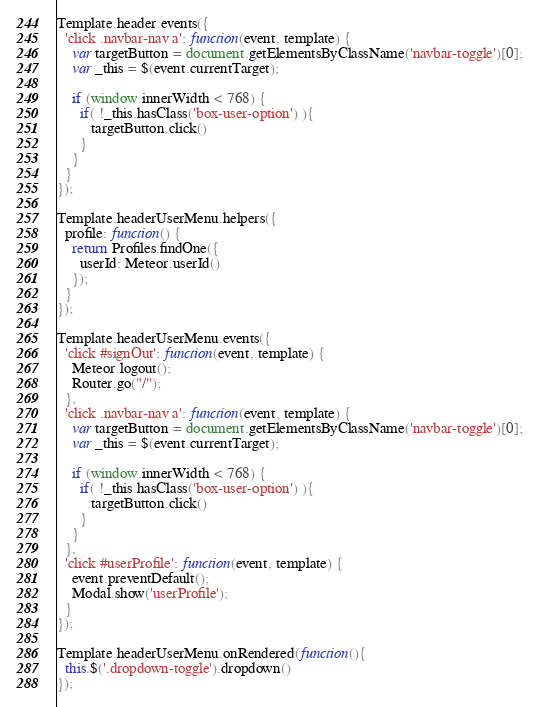Convert code to text. <code><loc_0><loc_0><loc_500><loc_500><_JavaScript_>Template.header.events({
  'click .navbar-nav a': function(event, template) {
    var targetButton = document.getElementsByClassName('navbar-toggle')[0];
    var _this = $(event.currentTarget); 

    if (window.innerWidth < 768) {
      if( !_this.hasClass('box-user-option') ){
         targetButton.click()
      }
    }
  }
});

Template.headerUserMenu.helpers({
  profile: function() {
    return Profiles.findOne({
      userId: Meteor.userId()
    });
  }
});

Template.headerUserMenu.events({
  'click #signOut': function(event, template) {
    Meteor.logout();
    Router.go("/");
  },
  'click .navbar-nav a': function(event, template) {
    var targetButton = document.getElementsByClassName('navbar-toggle')[0];
    var _this = $(event.currentTarget); 

    if (window.innerWidth < 768) {
      if( !_this.hasClass('box-user-option') ){
         targetButton.click()
      }
    }
  },
  'click #userProfile': function(event, template) {
    event.preventDefault();
    Modal.show('userProfile');
  }
});

Template.headerUserMenu.onRendered(function(){
  this.$('.dropdown-toggle').dropdown()
});
</code> 